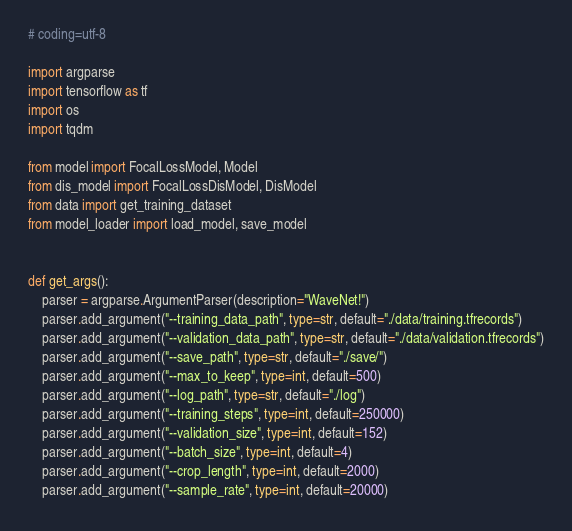<code> <loc_0><loc_0><loc_500><loc_500><_Python_># coding=utf-8

import argparse
import tensorflow as tf
import os
import tqdm

from model import FocalLossModel, Model
from dis_model import FocalLossDisModel, DisModel
from data import get_training_dataset
from model_loader import load_model, save_model


def get_args():
    parser = argparse.ArgumentParser(description="WaveNet!")
    parser.add_argument("--training_data_path", type=str, default="./data/training.tfrecords")
    parser.add_argument("--validation_data_path", type=str, default="./data/validation.tfrecords")
    parser.add_argument("--save_path", type=str, default="./save/")
    parser.add_argument("--max_to_keep", type=int, default=500)
    parser.add_argument("--log_path", type=str, default="./log")
    parser.add_argument("--training_steps", type=int, default=250000)
    parser.add_argument("--validation_size", type=int, default=152)
    parser.add_argument("--batch_size", type=int, default=4)
    parser.add_argument("--crop_length", type=int, default=2000)
    parser.add_argument("--sample_rate", type=int, default=20000)</code> 